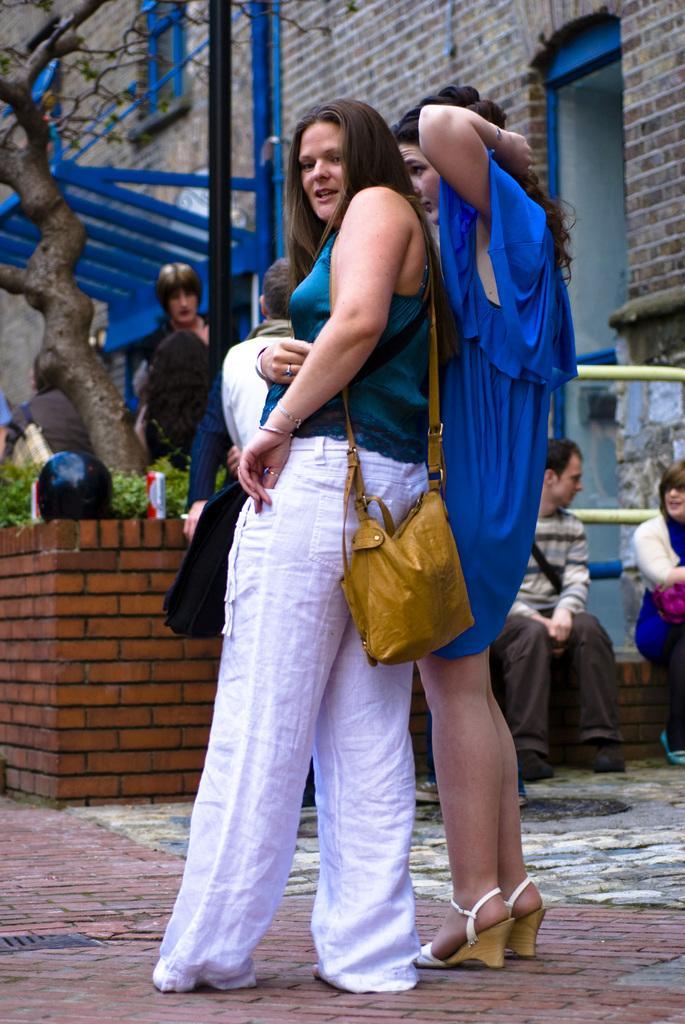Can you describe this image briefly? In this picture I can see few people standing and two persons sitting on the wall. I can see plants, tree, and in the background there is a building. 